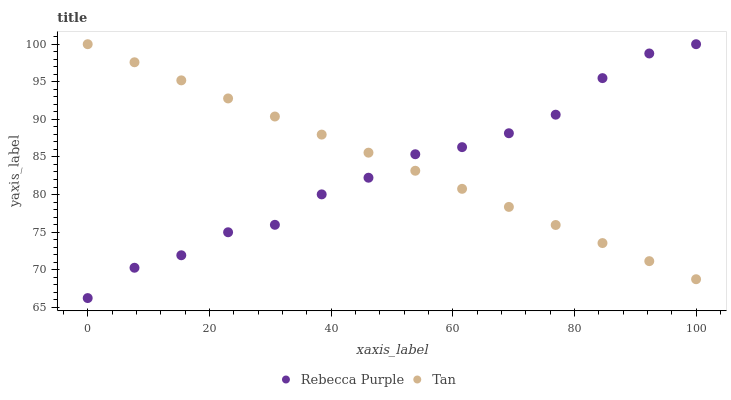Does Rebecca Purple have the minimum area under the curve?
Answer yes or no. Yes. Does Tan have the maximum area under the curve?
Answer yes or no. Yes. Does Rebecca Purple have the maximum area under the curve?
Answer yes or no. No. Is Tan the smoothest?
Answer yes or no. Yes. Is Rebecca Purple the roughest?
Answer yes or no. Yes. Is Rebecca Purple the smoothest?
Answer yes or no. No. Does Rebecca Purple have the lowest value?
Answer yes or no. Yes. Does Rebecca Purple have the highest value?
Answer yes or no. Yes. Does Tan intersect Rebecca Purple?
Answer yes or no. Yes. Is Tan less than Rebecca Purple?
Answer yes or no. No. Is Tan greater than Rebecca Purple?
Answer yes or no. No. 